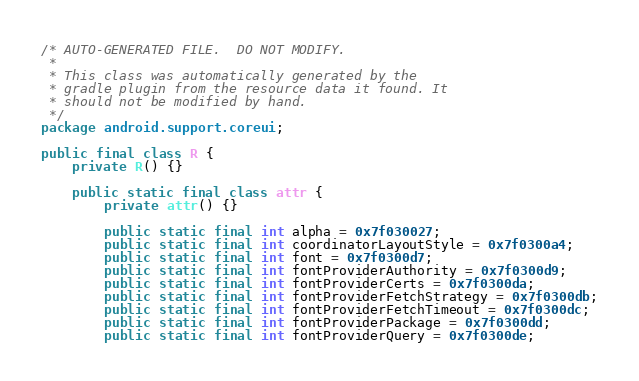<code> <loc_0><loc_0><loc_500><loc_500><_Java_>/* AUTO-GENERATED FILE.  DO NOT MODIFY.
 *
 * This class was automatically generated by the
 * gradle plugin from the resource data it found. It
 * should not be modified by hand.
 */
package android.support.coreui;

public final class R {
    private R() {}

    public static final class attr {
        private attr() {}

        public static final int alpha = 0x7f030027;
        public static final int coordinatorLayoutStyle = 0x7f0300a4;
        public static final int font = 0x7f0300d7;
        public static final int fontProviderAuthority = 0x7f0300d9;
        public static final int fontProviderCerts = 0x7f0300da;
        public static final int fontProviderFetchStrategy = 0x7f0300db;
        public static final int fontProviderFetchTimeout = 0x7f0300dc;
        public static final int fontProviderPackage = 0x7f0300dd;
        public static final int fontProviderQuery = 0x7f0300de;</code> 